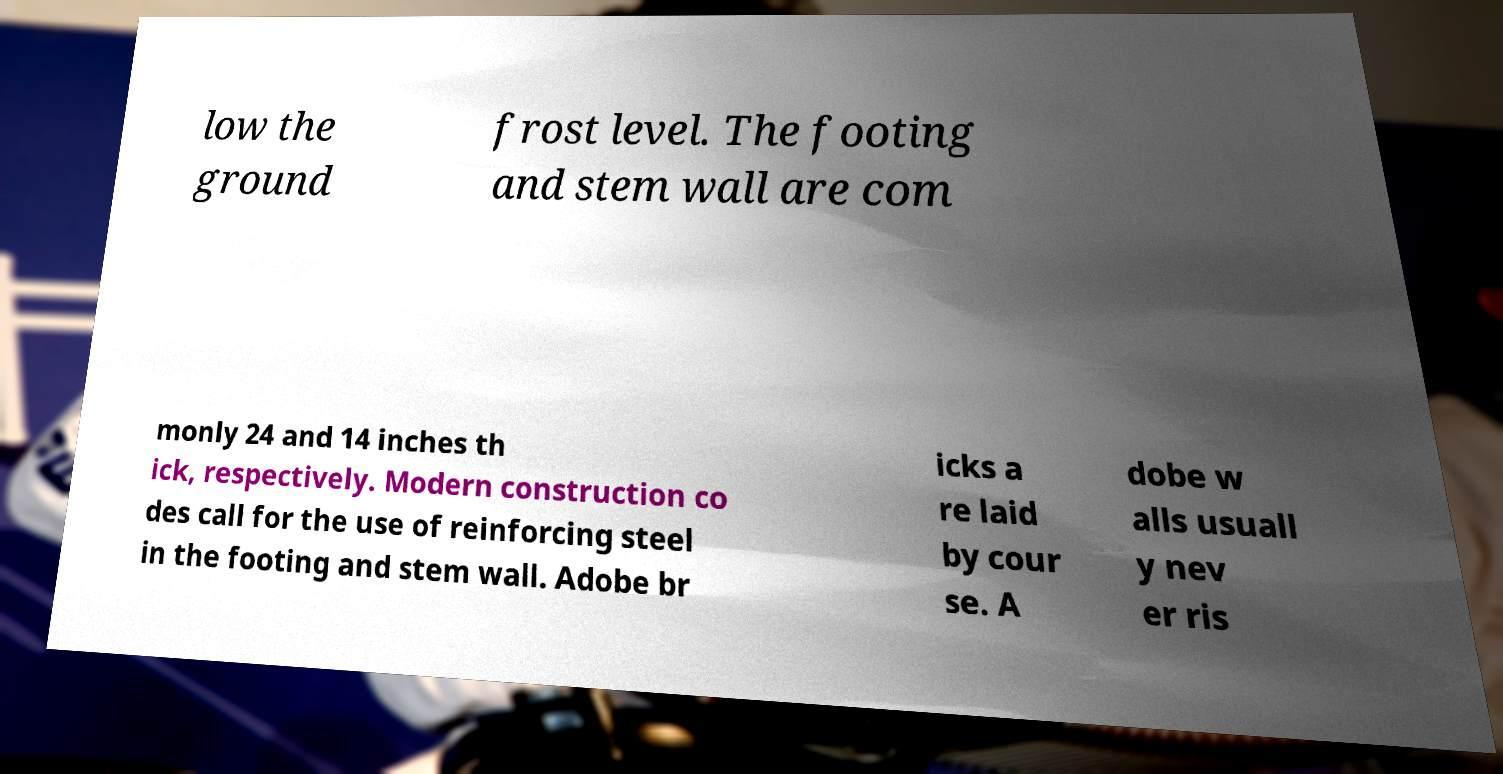What messages or text are displayed in this image? I need them in a readable, typed format. low the ground frost level. The footing and stem wall are com monly 24 and 14 inches th ick, respectively. Modern construction co des call for the use of reinforcing steel in the footing and stem wall. Adobe br icks a re laid by cour se. A dobe w alls usuall y nev er ris 